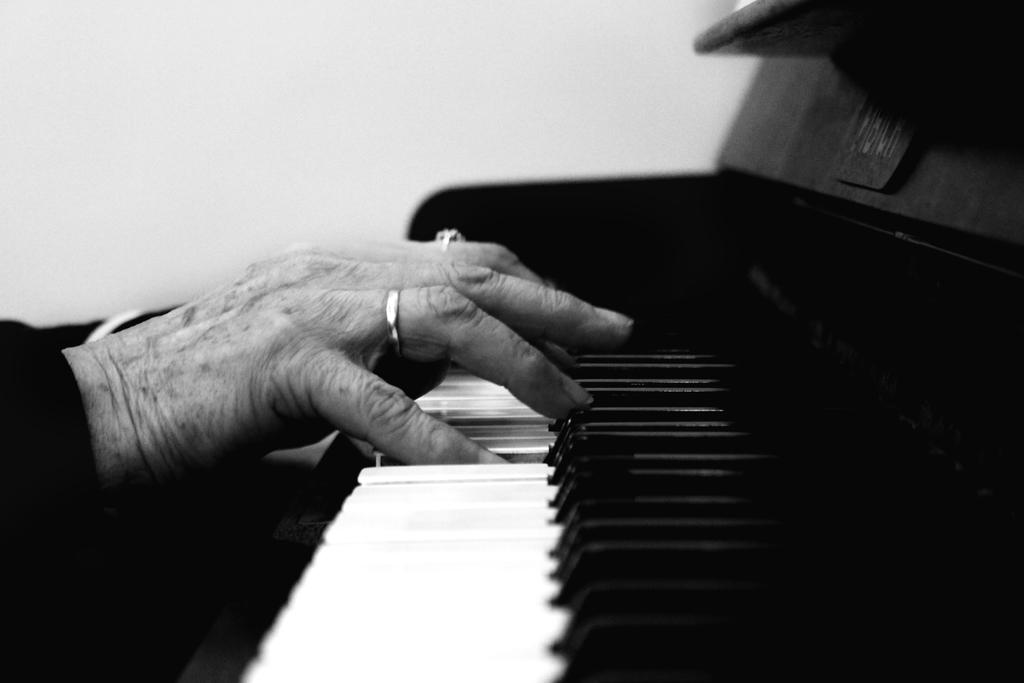What is the color of the wall in the image? The wall in the image is white. What is the person in the image doing? The person is playing a musical keyboard. How many types of keys are on the musical keyboard? The musical keyboard has black and white keys. What type of drink is being served on the island in the image? There is no island or drink present in the image; it features a person playing a musical keyboard with a white wall in the background. 